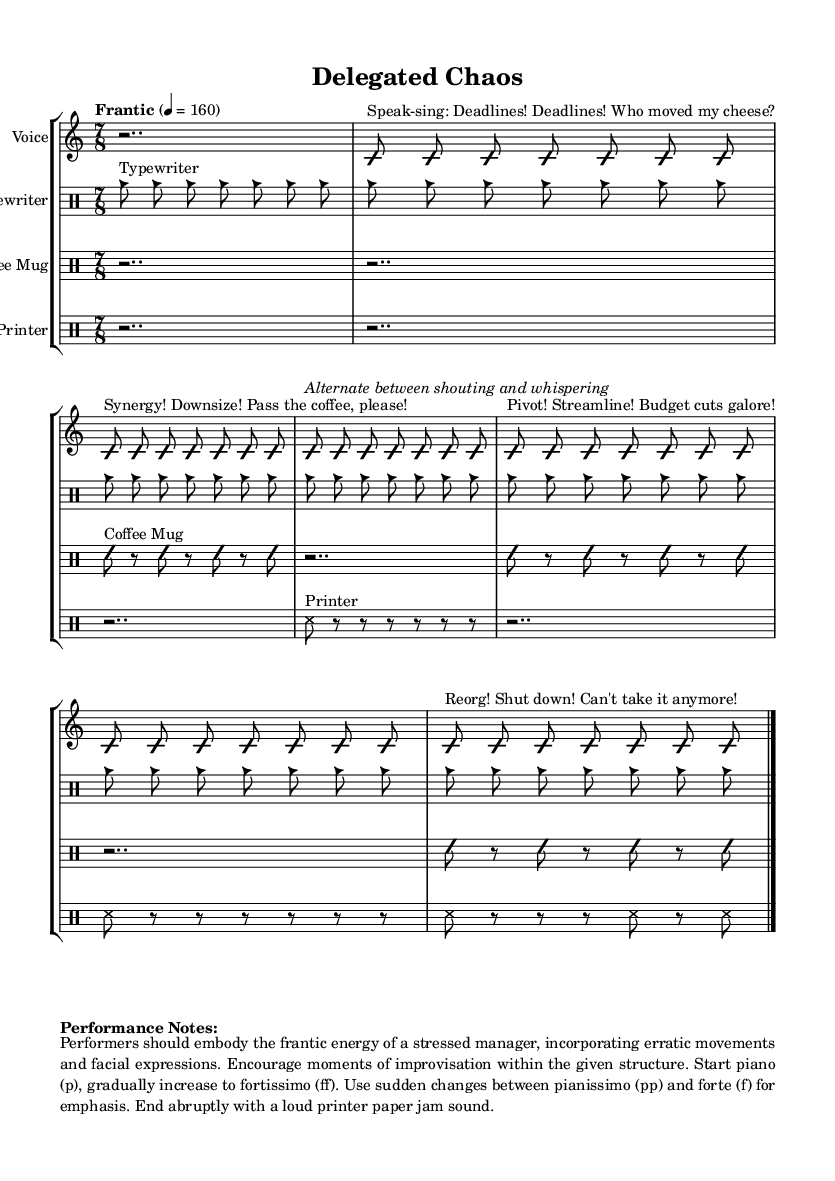What is the time signature of this music? The time signature is indicated at the beginning of the score, displaying "7/8". This means there are seven beats in each measure, and the eighth note gets one beat.
Answer: 7/8 What is the tempo marking? The tempo marking is found just before the music begins, stating "Frantic" and the metronome marking of 4 = 160. This indicates a fast-paced performance.
Answer: Frantic, 4 = 160 Which instrument accompanies the vocal arrangement? By examining the score, we see multiple drum parts listed: Typewriter, Coffee Mug, and Printer, which accompany the vocal arrangement.
Answer: Typewriter, Coffee Mug, Printer What dynamics are used in the performance? The performance notes detail dynamics throughout, mentioning starting piano (p), increasing to fortissimo (ff), and including sudden changes to pianissimo (pp) and forte (f).
Answer: piano, fortissimo, pianissimo, forte How are the vocal phrases structured in this piece? Looking at the voice part, it is clear that the phrases are based on stressed manager monologues, alternating between shouting and whispering, reflecting the frantic nature of a stressed middle manager.
Answer: Alternating between shouting and whispering What is the purpose of improvisation in this piece? The performance notes indicate that improvisation is encouraged, allowing performers to embody the frantic energy described. This supports the avant-garde style by adding spontaneity.
Answer: Encouraged for energy and spontaneity 